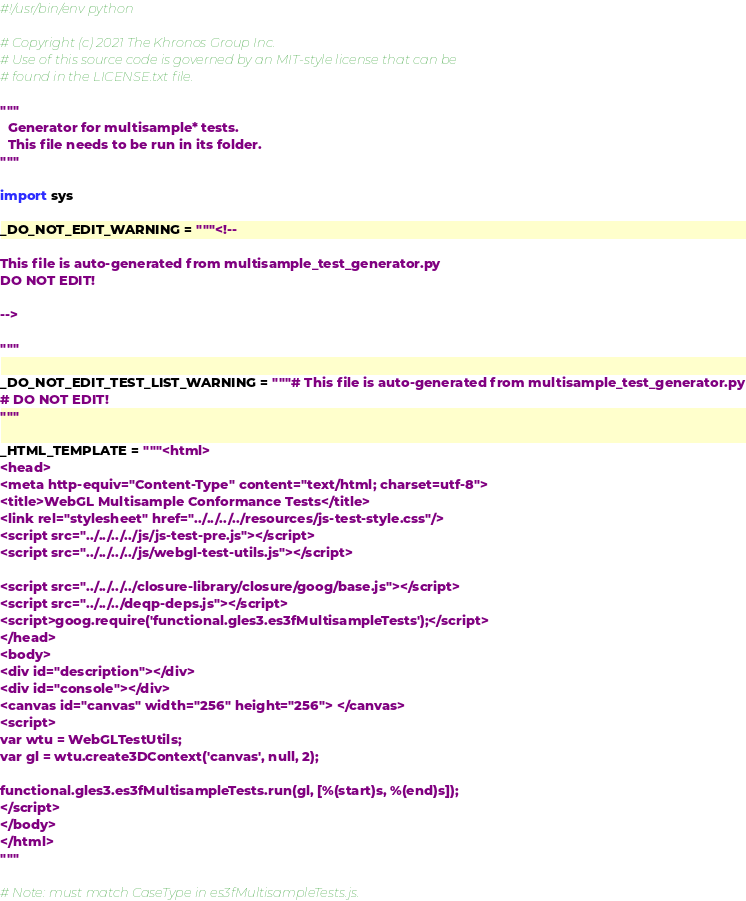<code> <loc_0><loc_0><loc_500><loc_500><_Python_>#!/usr/bin/env python

# Copyright (c) 2021 The Khronos Group Inc.
# Use of this source code is governed by an MIT-style license that can be
# found in the LICENSE.txt file.

"""
  Generator for multisample* tests.
  This file needs to be run in its folder.
"""

import sys

_DO_NOT_EDIT_WARNING = """<!--

This file is auto-generated from multisample_test_generator.py
DO NOT EDIT!

-->

"""

_DO_NOT_EDIT_TEST_LIST_WARNING = """# This file is auto-generated from multisample_test_generator.py
# DO NOT EDIT!
"""

_HTML_TEMPLATE = """<html>
<head>
<meta http-equiv="Content-Type" content="text/html; charset=utf-8">
<title>WebGL Multisample Conformance Tests</title>
<link rel="stylesheet" href="../../../../resources/js-test-style.css"/>
<script src="../../../../js/js-test-pre.js"></script>
<script src="../../../../js/webgl-test-utils.js"></script>

<script src="../../../../closure-library/closure/goog/base.js"></script>
<script src="../../../deqp-deps.js"></script>
<script>goog.require('functional.gles3.es3fMultisampleTests');</script>
</head>
<body>
<div id="description"></div>
<div id="console"></div>
<canvas id="canvas" width="256" height="256"> </canvas>
<script>
var wtu = WebGLTestUtils;
var gl = wtu.create3DContext('canvas', null, 2);

functional.gles3.es3fMultisampleTests.run(gl, [%(start)s, %(end)s]);
</script>
</body>
</html>
"""

# Note: must match CaseType in es3fMultisampleTests.js.</code> 